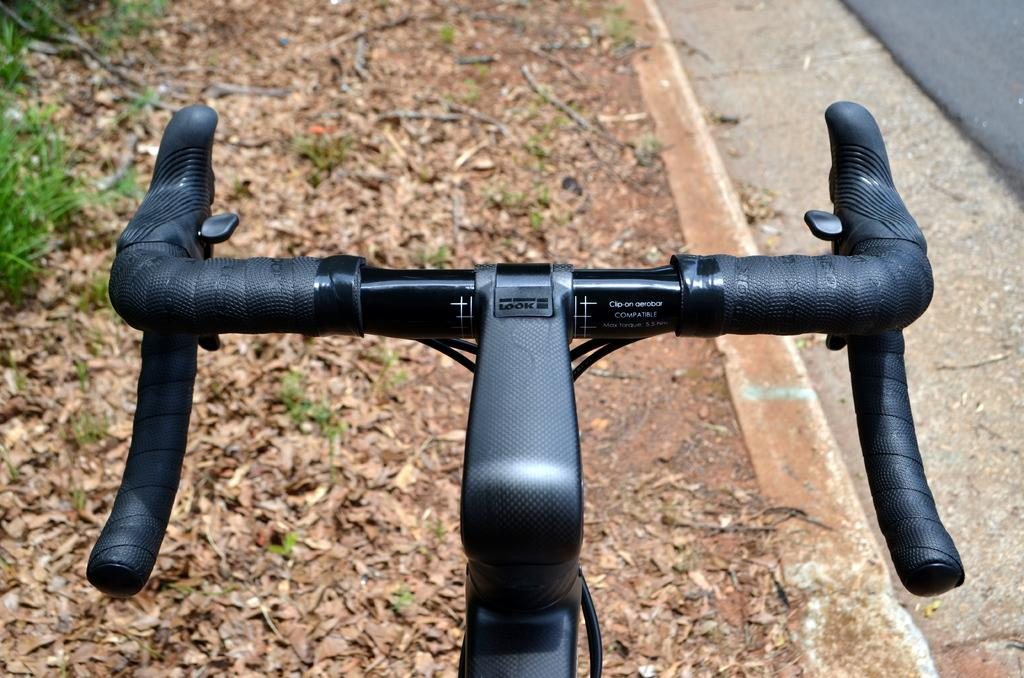What is the main object in the image? There is a bicycle in the image. What can be seen at the bottom of the image? Dried leaves are present at the bottom of the image. What is located on the right side of the image? There is a road on the right side of the image. What type of pear is hanging from the bicycle in the image? There is no pear present in the image, and it is not hanging from the bicycle. 